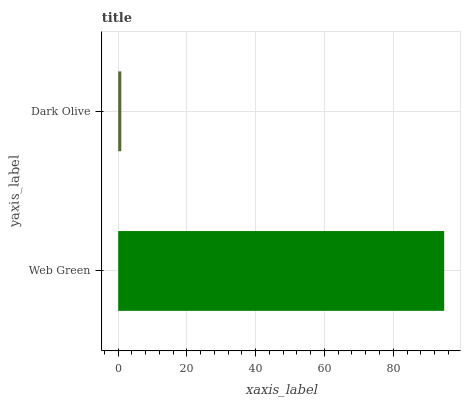Is Dark Olive the minimum?
Answer yes or no. Yes. Is Web Green the maximum?
Answer yes or no. Yes. Is Dark Olive the maximum?
Answer yes or no. No. Is Web Green greater than Dark Olive?
Answer yes or no. Yes. Is Dark Olive less than Web Green?
Answer yes or no. Yes. Is Dark Olive greater than Web Green?
Answer yes or no. No. Is Web Green less than Dark Olive?
Answer yes or no. No. Is Web Green the high median?
Answer yes or no. Yes. Is Dark Olive the low median?
Answer yes or no. Yes. Is Dark Olive the high median?
Answer yes or no. No. Is Web Green the low median?
Answer yes or no. No. 